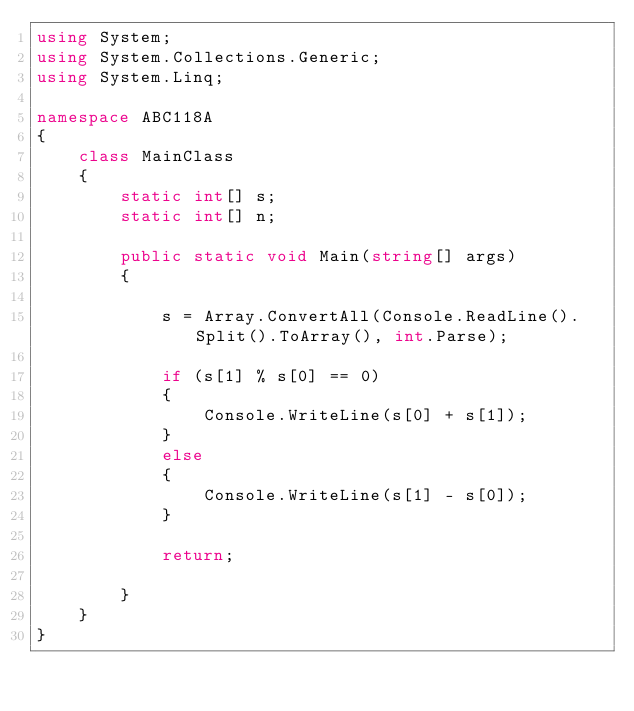<code> <loc_0><loc_0><loc_500><loc_500><_C#_>using System;
using System.Collections.Generic;
using System.Linq;

namespace ABC118A
{
    class MainClass
    {
        static int[] s;
        static int[] n;

        public static void Main(string[] args)
        {

            s = Array.ConvertAll(Console.ReadLine().Split().ToArray(), int.Parse);

            if (s[1] % s[0] == 0)
            {
                Console.WriteLine(s[0] + s[1]);
            }
            else
            {
                Console.WriteLine(s[1] - s[0]);
            }

            return;

        }
    }
}
</code> 